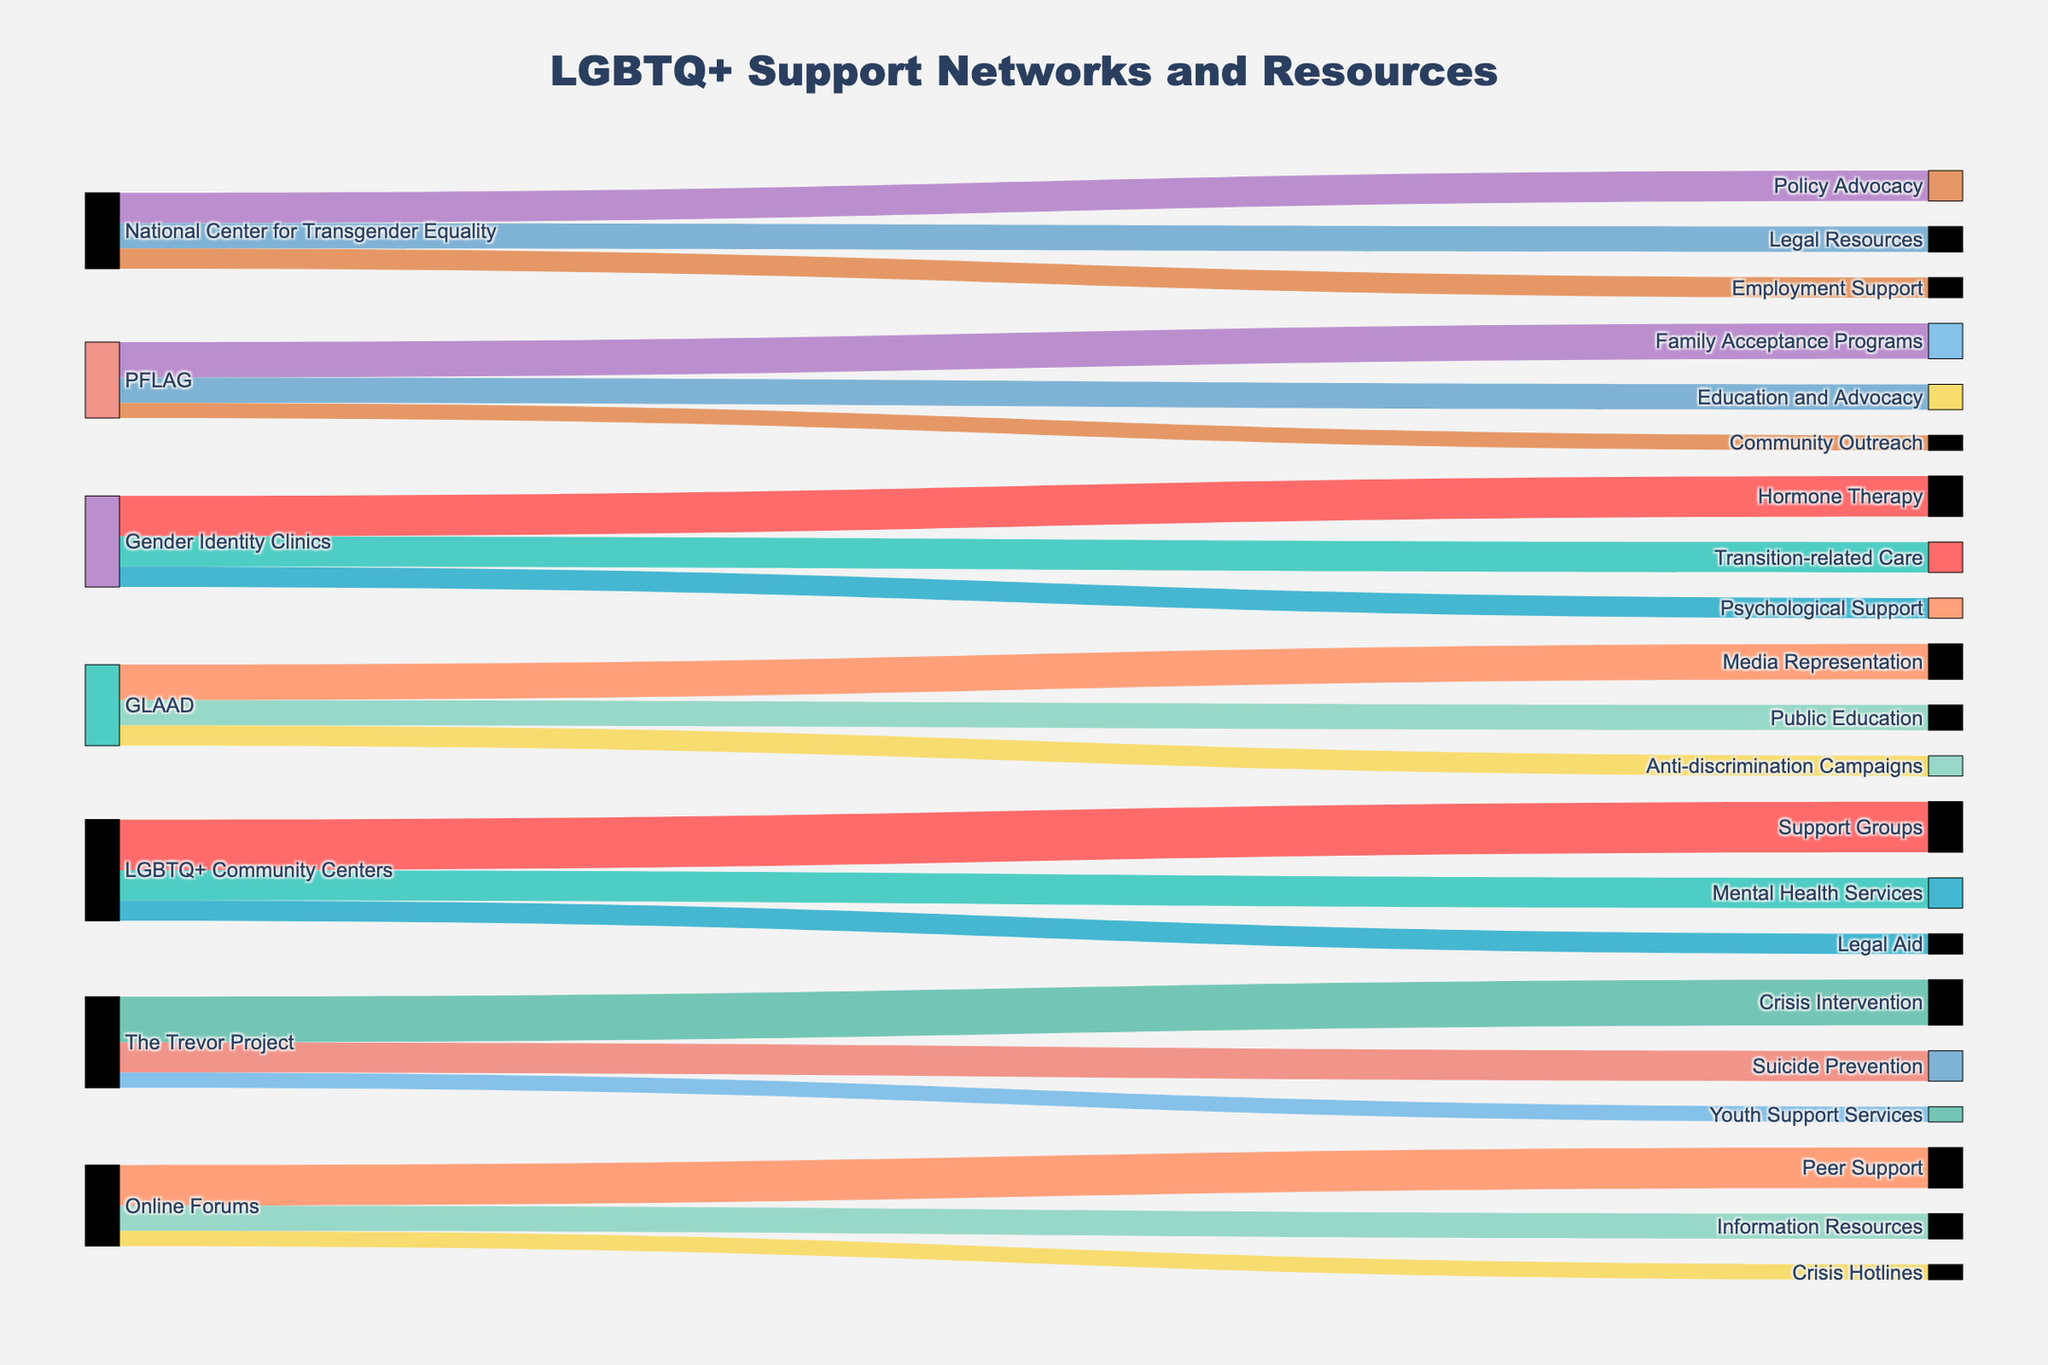What is the title of the Sankey Diagram? The title is typically found at the top of the diagram and acts as a header, providing a brief description of what the diagram represents. In this case, it gives us a clear indication of the focus of the diagram.
Answer: LGBTQ+ Support Networks and Resources Which source has the highest number of connections to destinations? To determine the source with the most connections, count the number of links originating from each source. The source with the highest count is the one with the most connections.
Answer: LGBTQ+ Community Centers How many total connections are there from Online Forums to its destinations? To find the total connections, sum the intermediate values that go from Online Forums to all its destinations. Add up 40 (Peer Support), 25 (Information Resources), and 15 (Crisis Hotlines).
Answer: 80 Which destination is linked to the highest number of sources? Count the number of unique sources that link to each destination. The destination with the highest count has the most sources linked to it.
Answer: Peer Support Which resource received the least number of connections from its source, LGBTQ+ Community Centers? To determine this, look at the intermediate values for all the connections from LGBTQ+ Community Centers and identify the smallest value. The values are 50 (Support Groups), 30 (Mental Health Services), and 20 (Legal Aid).
Answer: Legal Aid What is the combined total of individuals accessing resources from The Trevor Project? Add the intermediate values connecting from The Trevor Project to its destinations: 45 (Crisis Intervention), 30 (Suicide Prevention), and 15 (Youth Support Services).
Answer: 90 How many more people access Support Groups compared to Community Outreach programs? Identify the intermediate values connected to Support Groups and Community Outreach programs and subtract the latter from the former. Support Groups has a value of 50 and Community Outreach has 15.
Answer: 35 Which destination resources do Gender Identity Clinics provide besides Hormone Therapy? Observe all destinations linked from Gender Identity Clinics and list them, excluding Hormone Therapy. The destinations are Transition-related Care and Psychological Support.
Answer: Transition-related Care and Psychological Support Between Media Representation and Public Education, which resources provided by GLAAD have more access? Compare the intermediate values for Media Representation and Public Education. Media Representation is 35 and Public Education is 25.
Answer: Media Representation What percentage of PFLAG's connections are to Family Acceptance Programs? Calculate the ratio of the connections to Family Acceptance Programs (35) out of the total connections from PFLAG (sum of all intermediate values: 35 + 25 + 15), then multiply by 100. The total is 75, so (35/75) * 100.
Answer: 46.67% 